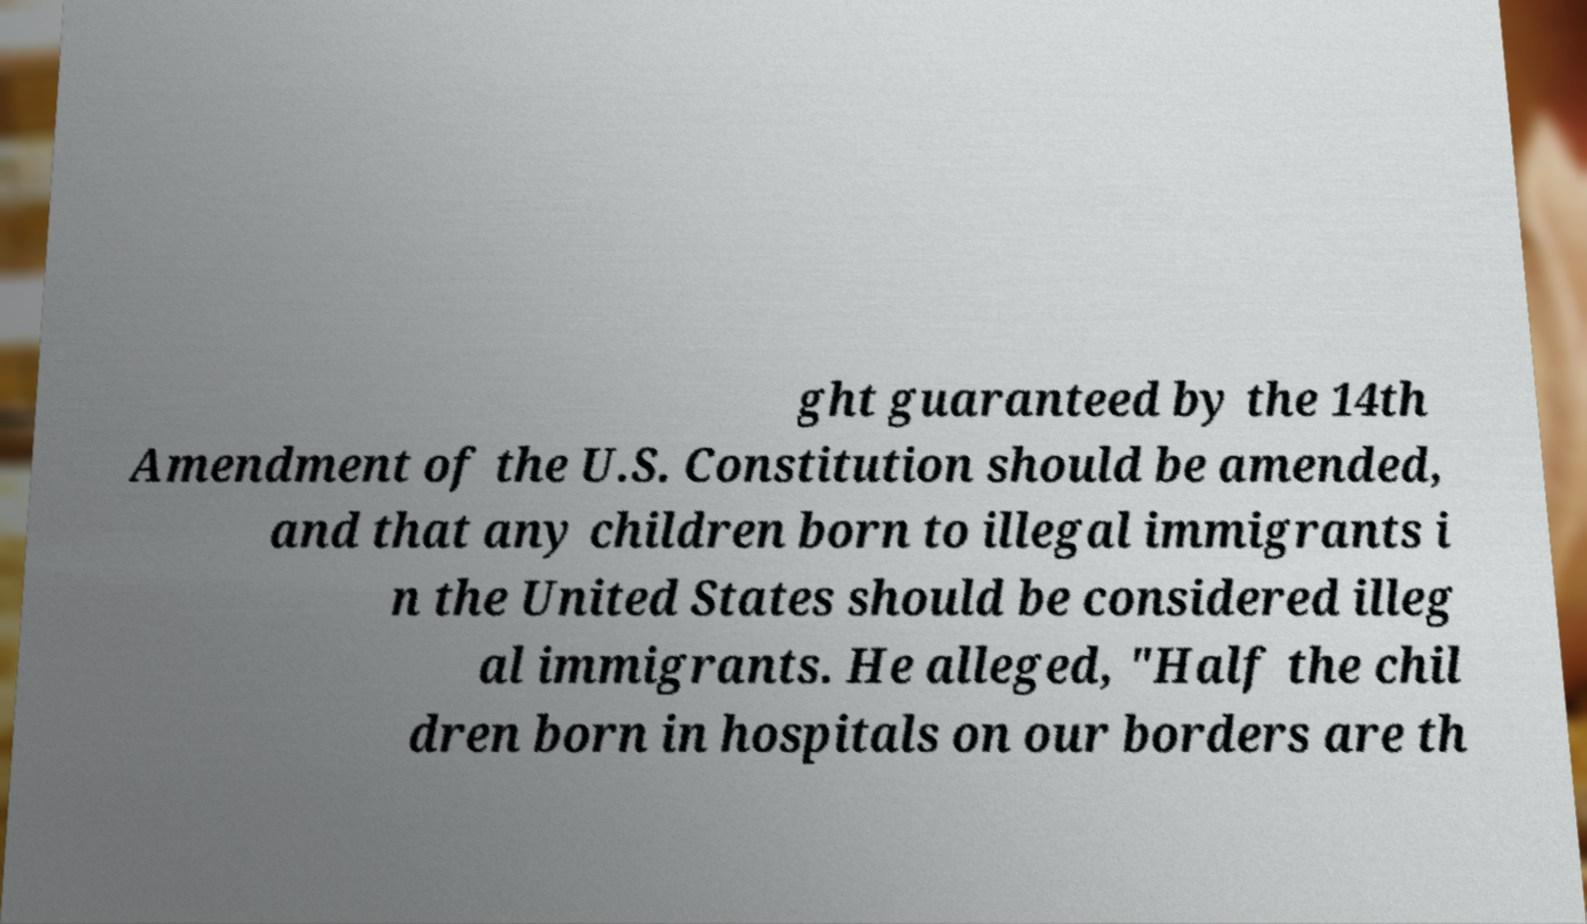What messages or text are displayed in this image? I need them in a readable, typed format. ght guaranteed by the 14th Amendment of the U.S. Constitution should be amended, and that any children born to illegal immigrants i n the United States should be considered illeg al immigrants. He alleged, "Half the chil dren born in hospitals on our borders are th 